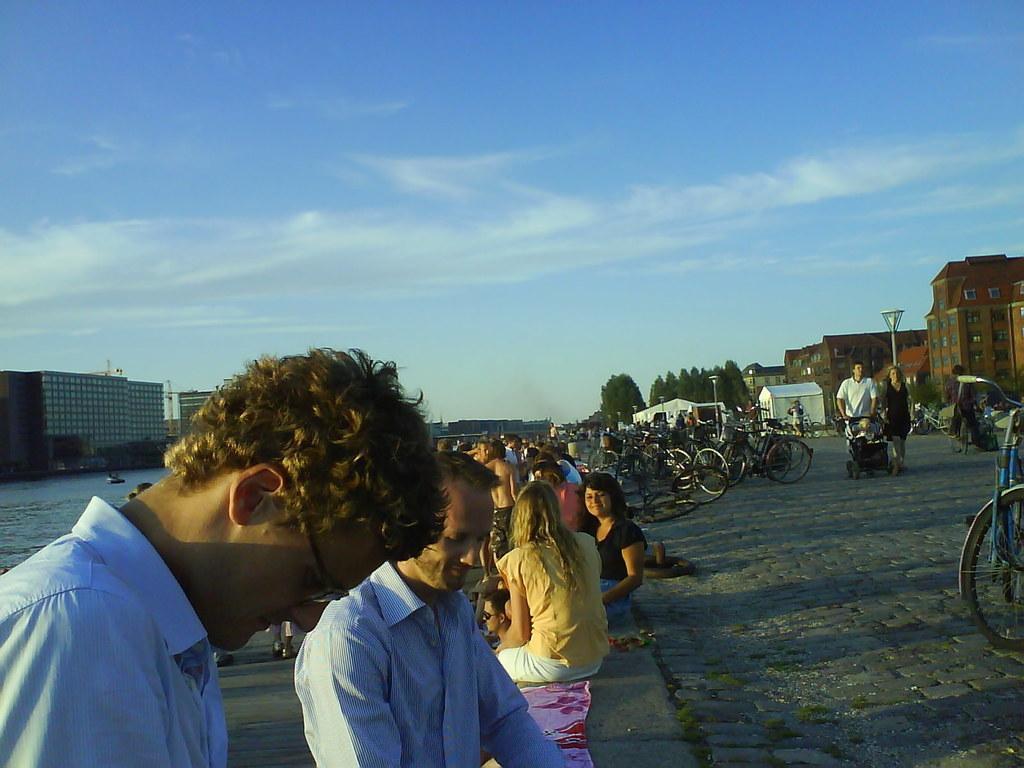Please provide a concise description of this image. In the center of the image there are people. There is a road on which there are bicycles. In the background of the image there are trees,buildings. To the left side of the image there is water. At the top of the image there is sky 